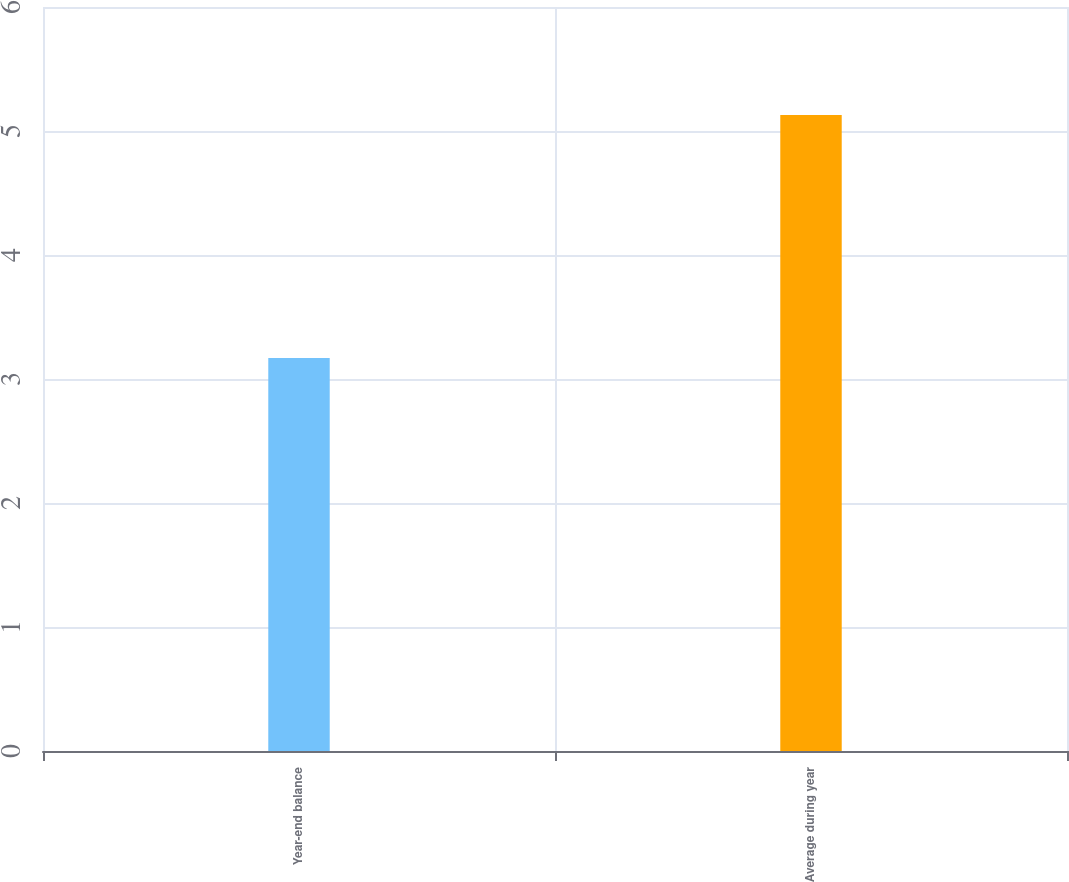Convert chart. <chart><loc_0><loc_0><loc_500><loc_500><bar_chart><fcel>Year-end balance<fcel>Average during year<nl><fcel>3.17<fcel>5.13<nl></chart> 